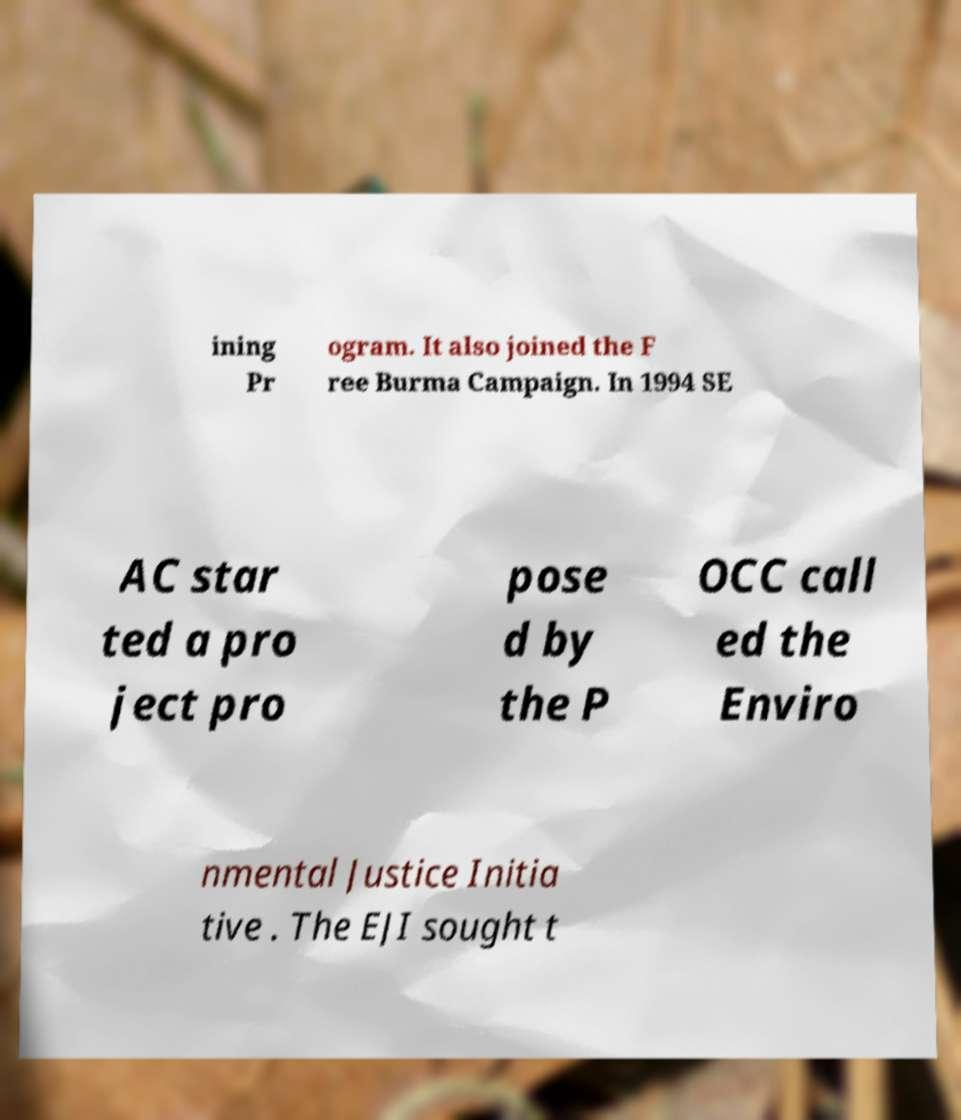Can you accurately transcribe the text from the provided image for me? ining Pr ogram. It also joined the F ree Burma Campaign. In 1994 SE AC star ted a pro ject pro pose d by the P OCC call ed the Enviro nmental Justice Initia tive . The EJI sought t 